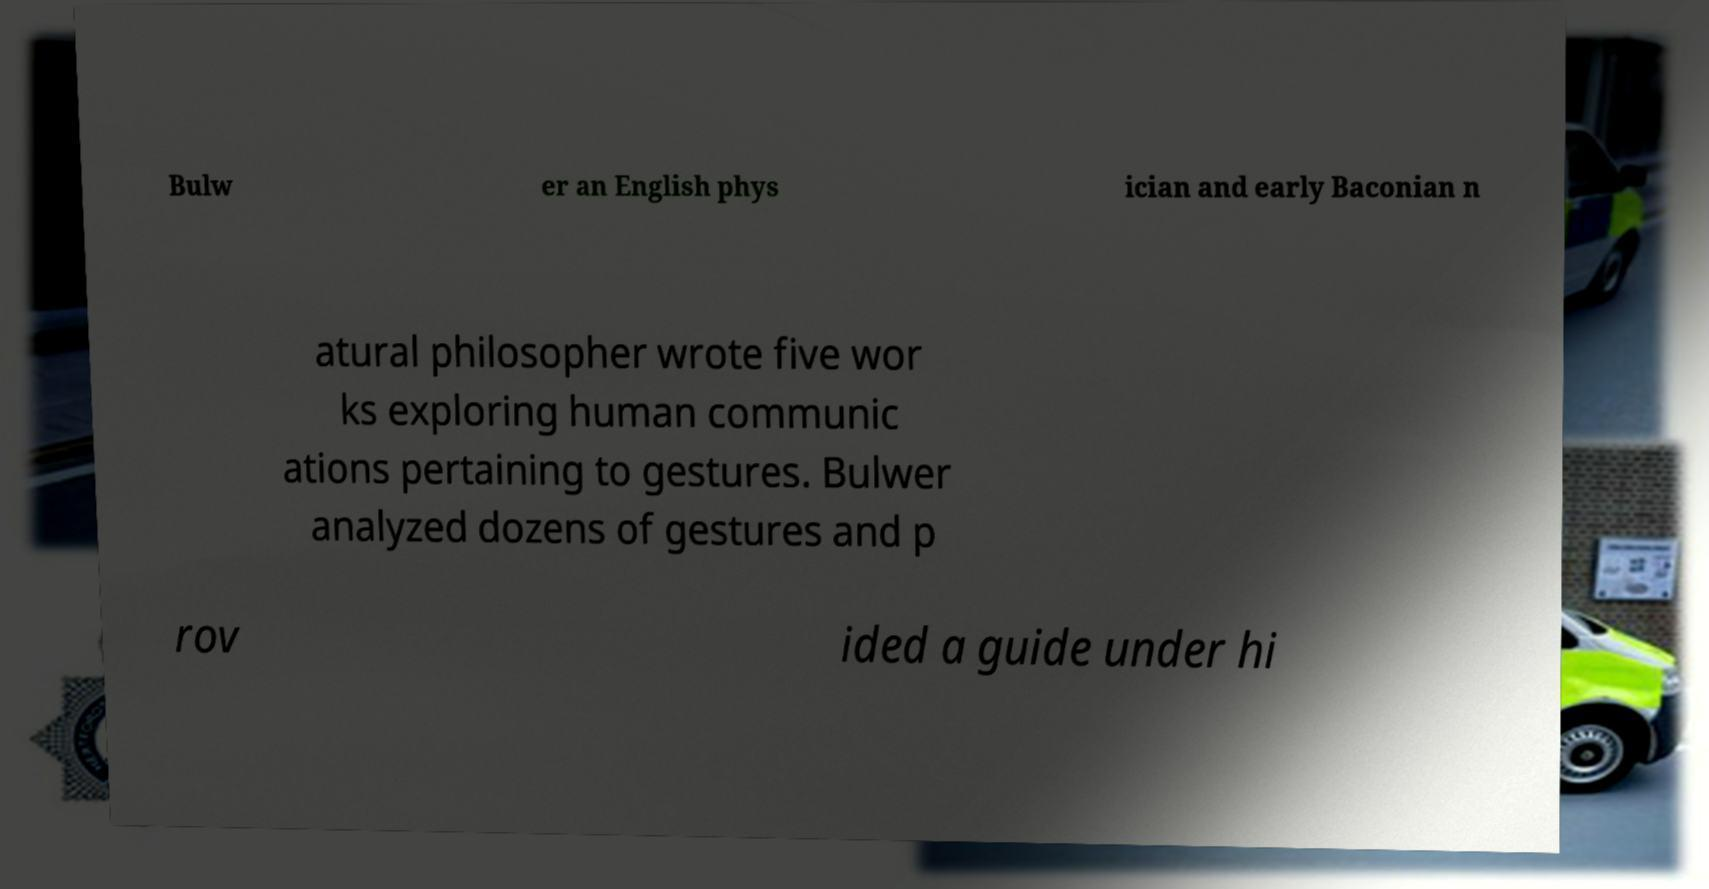I need the written content from this picture converted into text. Can you do that? Bulw er an English phys ician and early Baconian n atural philosopher wrote five wor ks exploring human communic ations pertaining to gestures. Bulwer analyzed dozens of gestures and p rov ided a guide under hi 